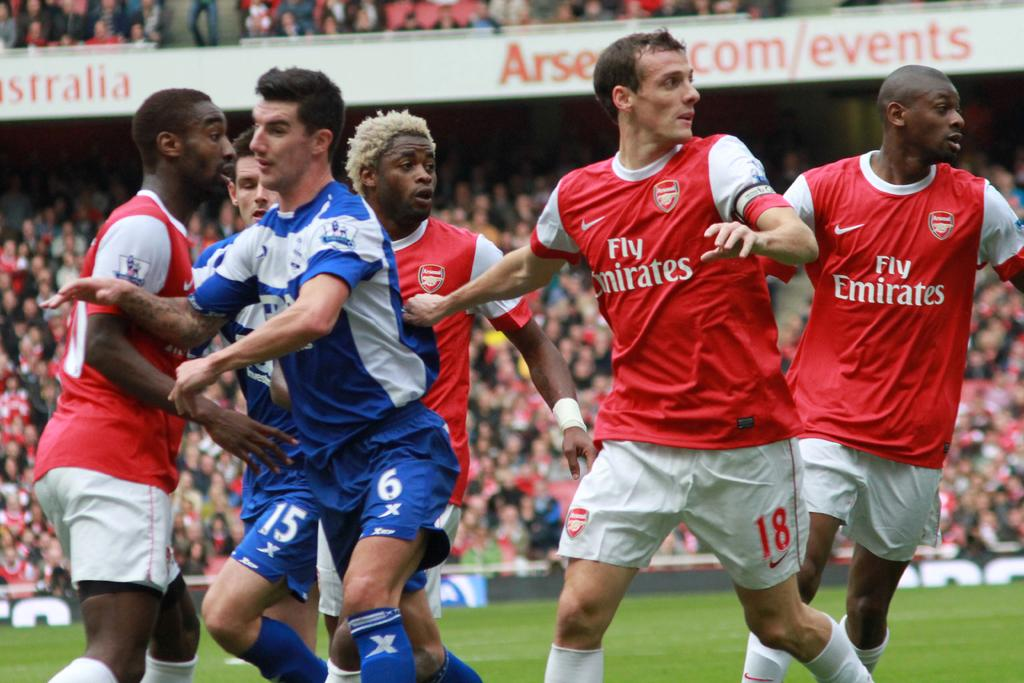<image>
Render a clear and concise summary of the photo. The red team is sponsored by Emirates and they are playing the blue team. 